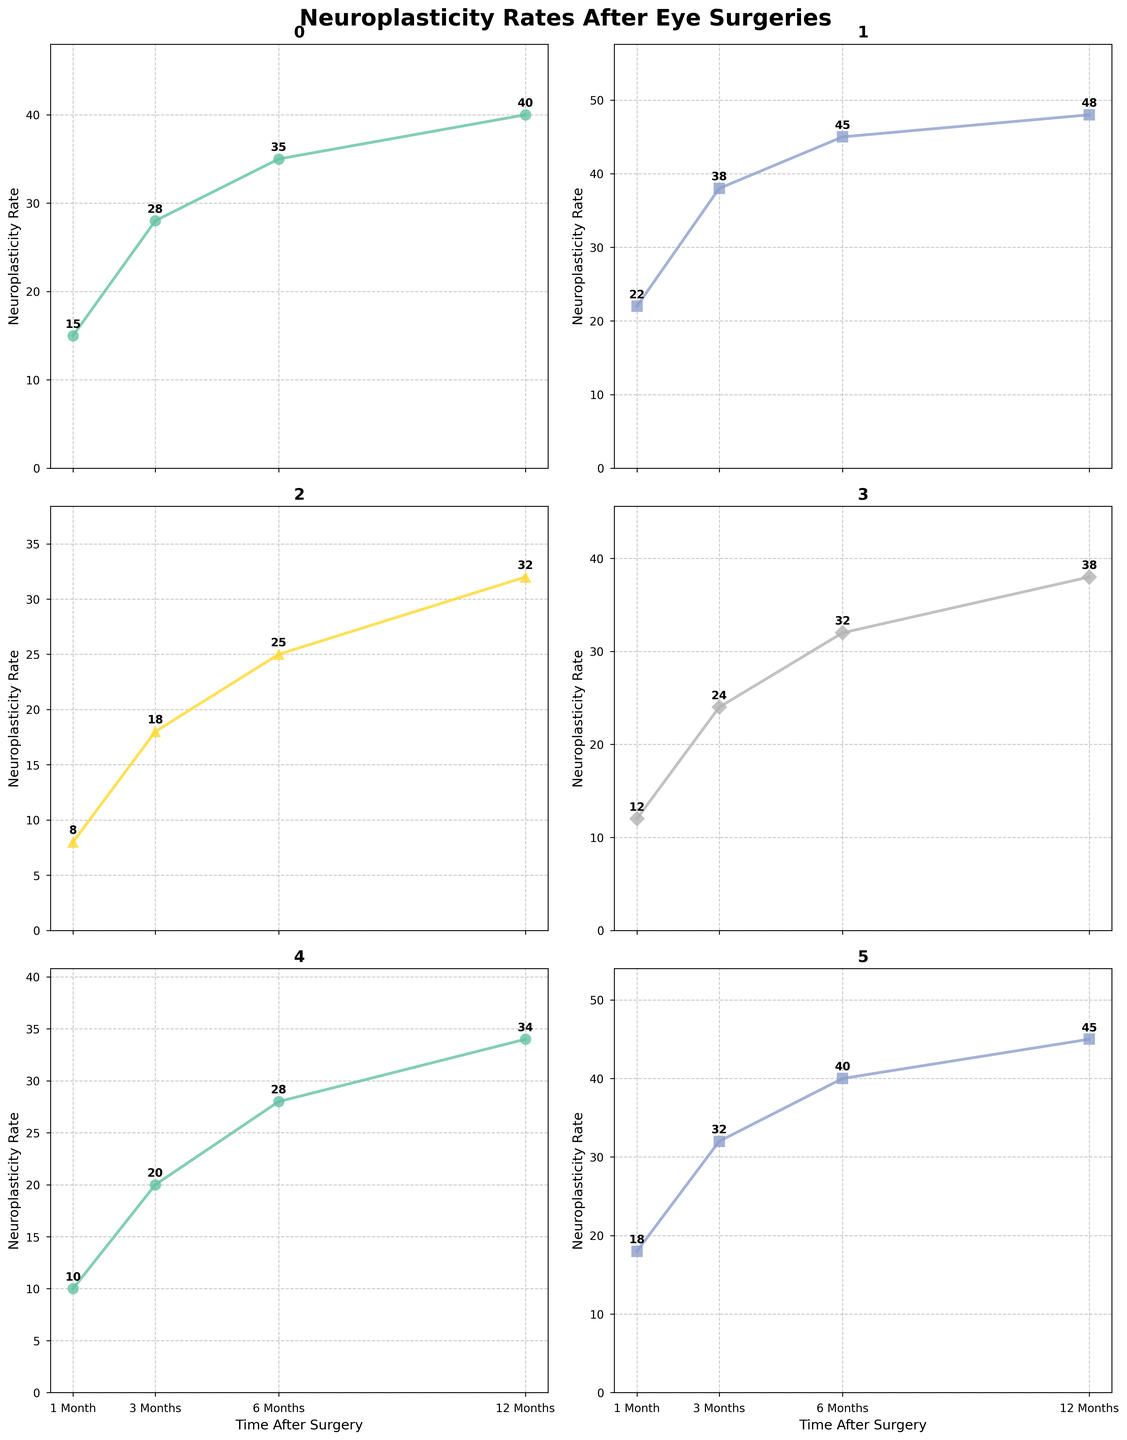Which surgery type shows the highest neuroplasticity rate at 1 month? By examining the first data point for each subplot, the highest value is 22 for LASIK at 1 month.
Answer: LASIK What's the average neuroplasticity rate for Glaucoma Surgery across all time points? Add the values for all time points (10 + 20 + 28 + 34) to get 92, then divide by 4 (92 / 4).
Answer: 23 Which surgery type exhibits the greatest increase in neuroplasticity rate between 1 and 3 months? Subtract the 1-month values from the 3-month values and compare differences. The differences are:
   - Cataract Surgery: 28 - 15 = 13
   - LASIK: 38 - 22 = 16
   - Retinal Detachment Repair: 18 - 8 = 10
   - Corneal Transplant: 24 - 12 = 12
   - Glaucoma Surgery: 20 - 10 = 10
   - Strabismus Surgery: 32 - 18 = 14 
The largest increase is for LASIK.
Answer: LASIK How does the neuroplasticity rate for Strabismus Surgery at 12 months compare to that of Cataract Surgery? By comparing the two values at 12 months, Strabismus Surgery has a rate of 45, while Cataract Surgery has a rate of 40.
Answer: It's higher for Strabismus Surgery What's the total neuroplasticity rate for Retinal Detachment Repair from 1 month to 12 months combined? Sum the values (8 + 18 + 25 + 32).
Answer: 83 Which two surgeries have the closest neuroplasticity rates at 6 months? Compare the 6-month values across all surgeries:
   - Cataract Surgery: 35
   - LASIK: 45
   - Retinal Detachment Repair: 25
   - Corneal Transplant: 32
   - Glaucoma Surgery: 28
   - Strabismus Surgery: 40
The closest pair is Glaucoma Surgery (28) and Corneal Transplant (32).
Answer: Glaucoma Surgery and Corneal Transplant Which surgery type has the steepest rate of increase in neuroplasticity from 6 months to 12 months? Calculate the difference between the 12-month and 6-month values for each surgery:
   - Cataract Surgery: 40 - 35 = 5
   - LASIK: 48 - 45 = 3
   - Retinal Detachment Repair: 32 - 25 = 7
   - Corneal Transplant: 38 - 32 = 6
   - Glaucoma Surgery: 34 - 28 = 6
   - Strabismus Surgery: 45 - 40 = 5 
The steepest increase is for Retinal Detachment Repair.
Answer: Retinal Detachment Repair Which surgery type maintains a consistent rank in neuroplasticity rate relative to other surgeries at each time point? By observation:
   - Cataract Surgery: Starts at 15, increases to 28, 35, 40
   - LASIK: Starts at 22, increases to 38, 45, 48
   - Retinal Detachment Repair: Starts at 8, increases to 18, 25, 32
   - Corneal Transplant: Starts at 12, increases to 24, 32, 38
   - Glaucoma Surgery: Starts at 10, increases to 20, 28, 34
   - Strabismus Surgery: Starts at 18, increases to 32, 40, 45 
LASIK consistently shows the highest rate at each time point.
Answer: LASIK 